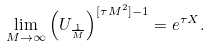Convert formula to latex. <formula><loc_0><loc_0><loc_500><loc_500>\lim _ { M \to \infty } \left ( U _ { \frac { 1 } { M } } \right ) ^ { [ \tau M ^ { 2 } ] - 1 } = e ^ { \tau X } .</formula> 